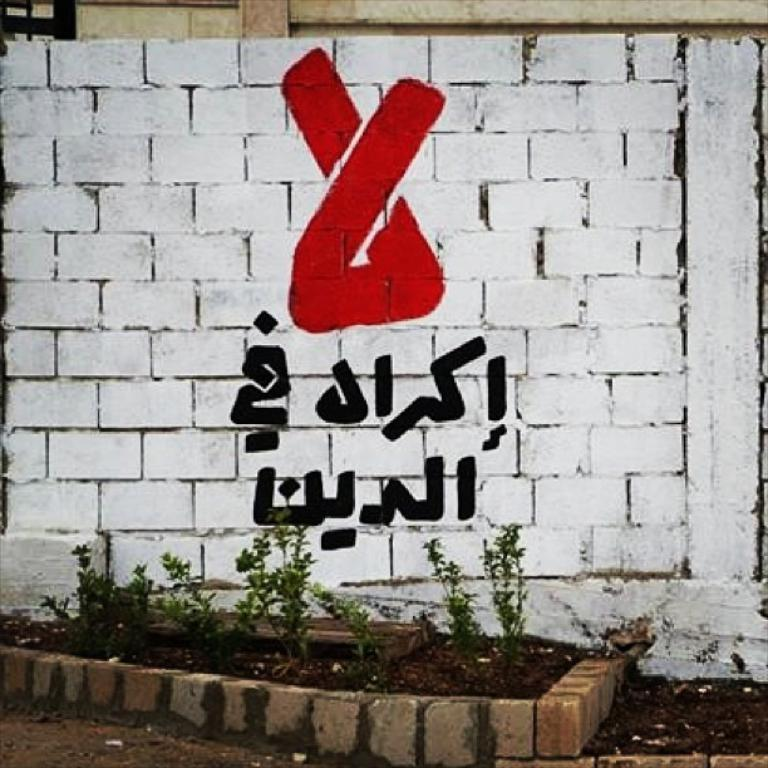What is on the wall in the image? There is a logo on the wall in the image. What else can be seen on the wall? There is something written on the wall. What is located near the wall? There are plants near the wall. What else is near the plants? There is a small brick wall near the plants. What is the weight of the tray in the image? There is no tray present in the image, so it is not possible to determine its weight. 